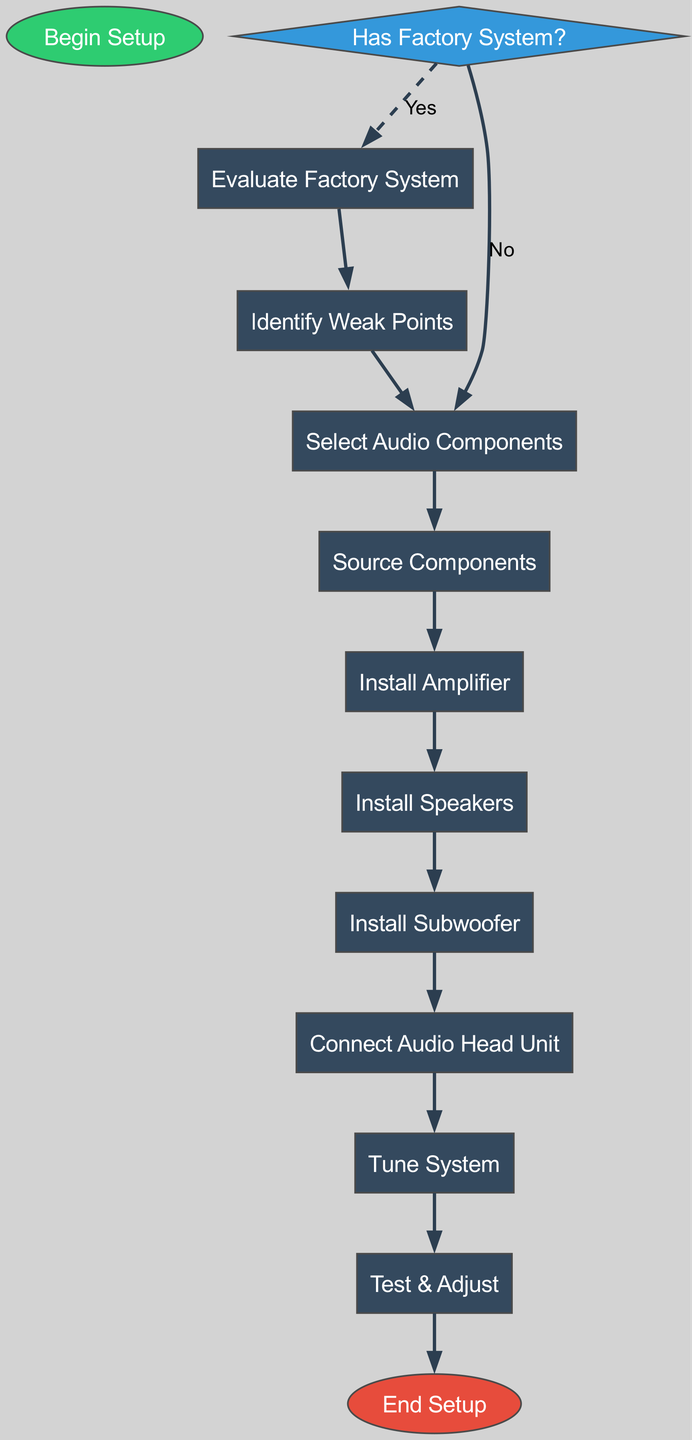What's the first step in the setup process? The first step is represented by the 'Start' node labeled "Begin Setup". This node initiates the workflow of the car audio system setup process.
Answer: Begin Setup How many decision nodes are in the diagram? The diagram contains one 'Decision' node labeled "Has Factory System?" This type of node represents a point where a choice must be made in the flowchart.
Answer: 1 What comes after selecting audio components? After selecting audio components, the next step is "Source Components", which is indicated by the connection from the 'Select Audio Components' process to the 'Source Components' process.
Answer: Source Components If the factory system is present, what process follows the evaluation? If the factory system is present, the next process after "Evaluate Factory System" is "Identify Weak Points", as shown by the flow from the 'Evaluate Factory System' process to the 'Identify Weak Points' process.
Answer: Identify Weak Points What is the final step in the setup process? The final step is represented by the 'End' node labeled "End Setup", which completes the workflow outlined in the diagram.
Answer: End Setup What are the last three processes of the setup? The last three processes are "Connect Audio Head Unit", "Tune System", and "Test & Adjust", as indicated in the flow from one process to the next in the latter part of the diagram.
Answer: Connect Audio Head Unit, Tune System, Test & Adjust Which process follows after the "Install Subwoofer"? The process that follows "Install Subwoofer" is "Connect Audio Head Unit". This can be seen from the directional edge connecting these two processes in the flowchart.
Answer: Connect Audio Head Unit What determines the path taken after "Has Factory System?" The path taken depends on whether the answer to "Has Factory System?" is yes or no; if yes, it leads to "Evaluate Factory System", and if no, it goes directly to "Select Audio Components".
Answer: Yes or No 